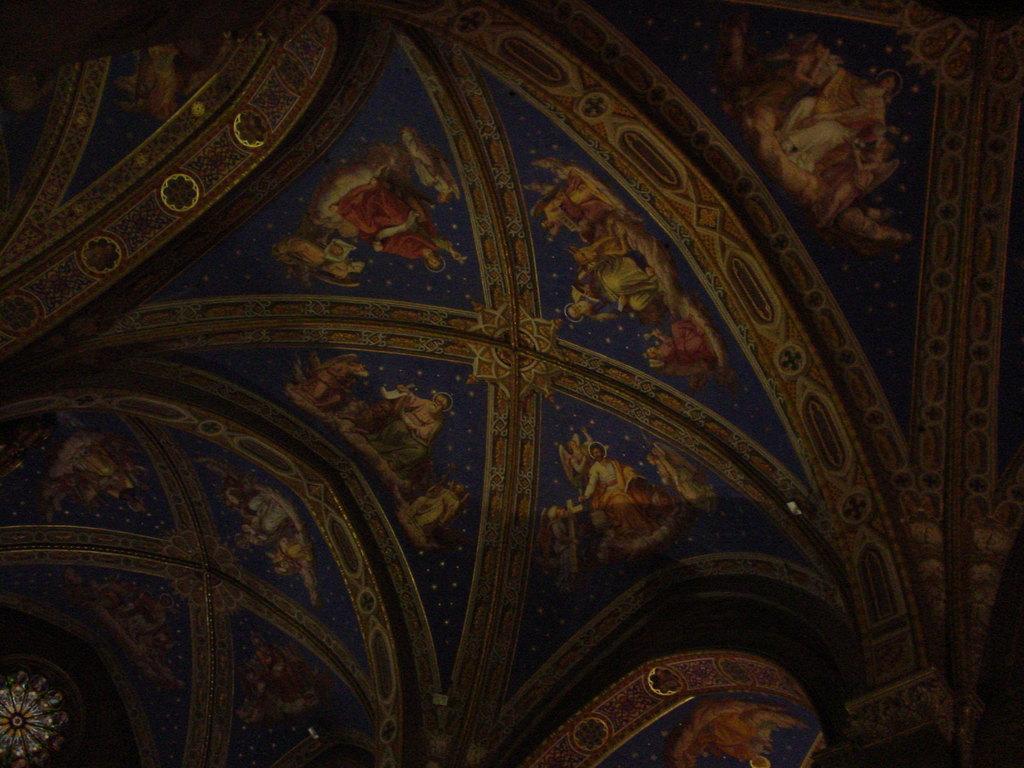Can you describe this image briefly? In this image we can see different pictures. 